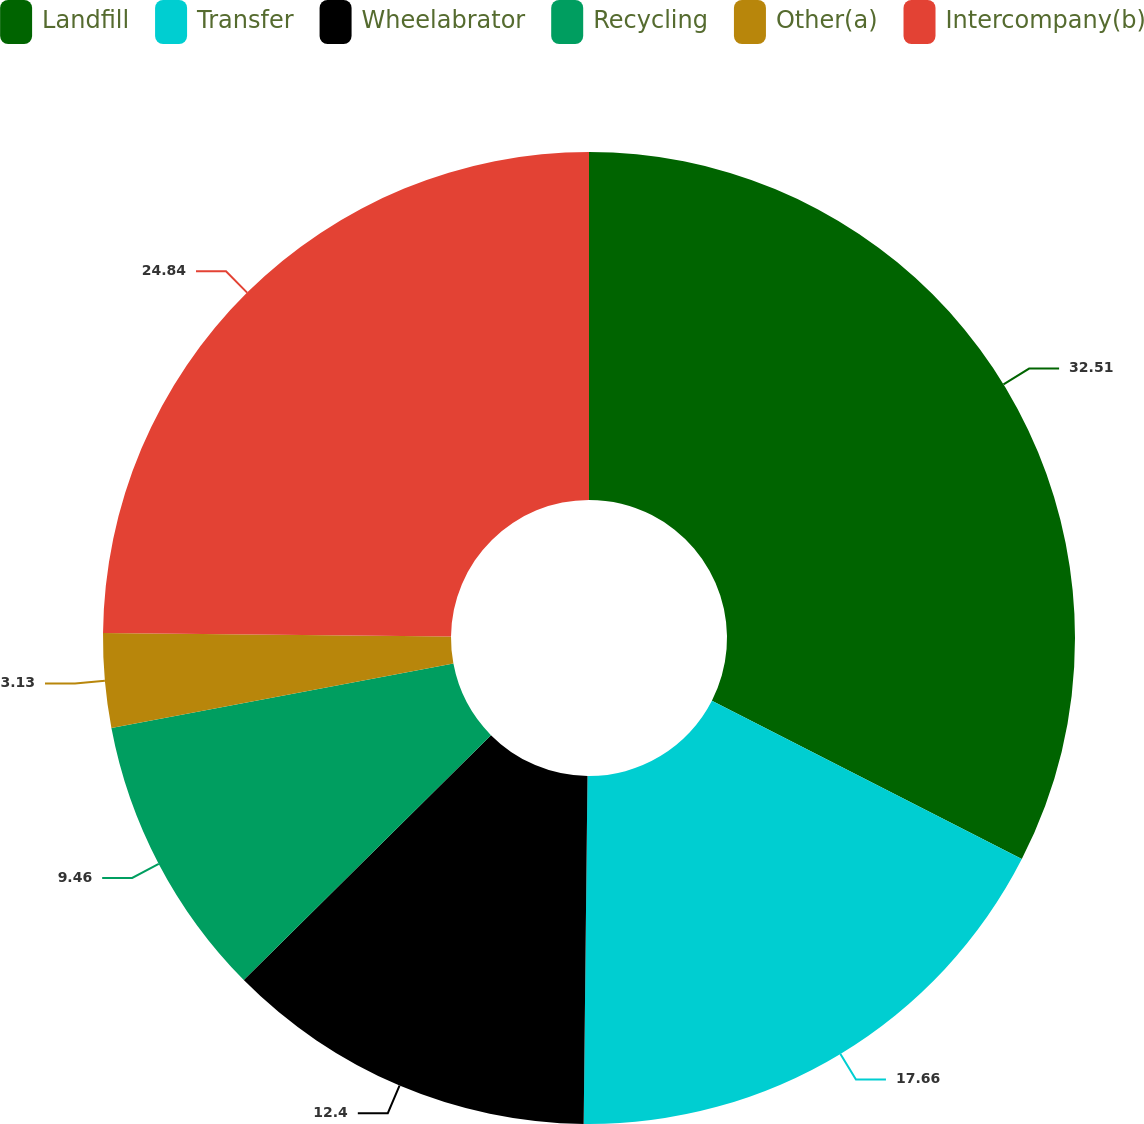Convert chart. <chart><loc_0><loc_0><loc_500><loc_500><pie_chart><fcel>Landfill<fcel>Transfer<fcel>Wheelabrator<fcel>Recycling<fcel>Other(a)<fcel>Intercompany(b)<nl><fcel>32.52%<fcel>17.66%<fcel>12.4%<fcel>9.46%<fcel>3.13%<fcel>24.84%<nl></chart> 